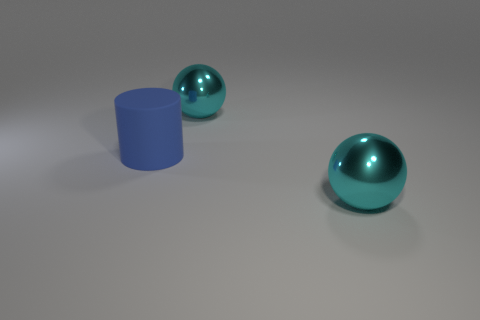There is a big ball in front of the blue cylinder; does it have the same color as the shiny thing behind the matte cylinder?
Give a very brief answer. Yes. How big is the cyan metal thing in front of the big rubber cylinder?
Ensure brevity in your answer.  Large. There is a cyan ball that is in front of the cyan ball behind the blue object; are there any big metallic balls that are behind it?
Provide a succinct answer. Yes. How many balls are either blue objects or large cyan things?
Your response must be concise. 2. What shape is the thing on the left side of the large shiny sphere behind the blue matte thing?
Provide a succinct answer. Cylinder. How big is the metal object to the right of the cyan ball that is behind the big cyan object that is in front of the rubber thing?
Offer a very short reply. Large. How many objects are big rubber objects or cyan shiny objects?
Offer a very short reply. 3. What is the size of the thing that is left of the shiny sphere that is behind the large cylinder?
Your answer should be very brief. Large. What size is the cylinder?
Your answer should be very brief. Large. What number of objects are either large cyan objects in front of the matte thing or big cyan metallic balls that are behind the rubber thing?
Keep it short and to the point. 2. 